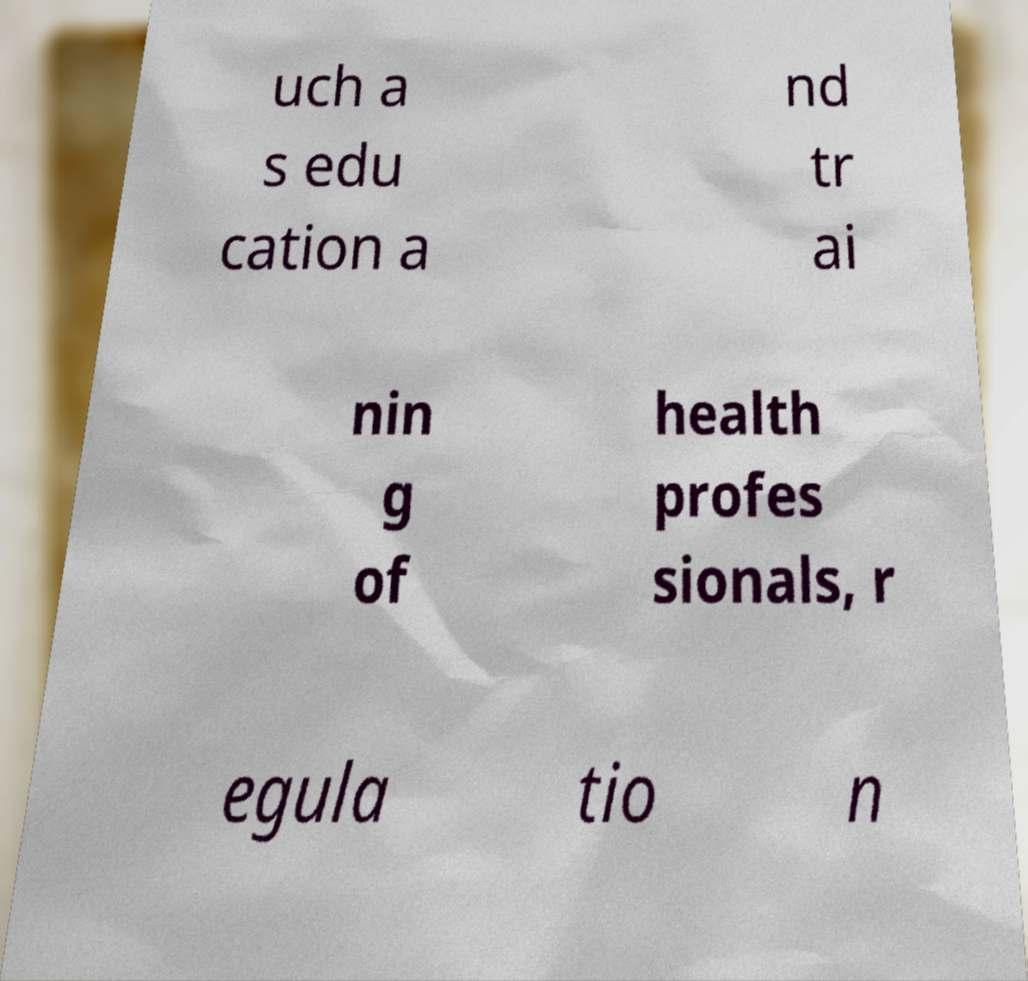Please identify and transcribe the text found in this image. uch a s edu cation a nd tr ai nin g of health profes sionals, r egula tio n 